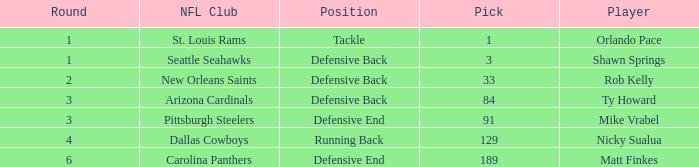What player has defensive back as the position, with a round less than 2? Shawn Springs. 